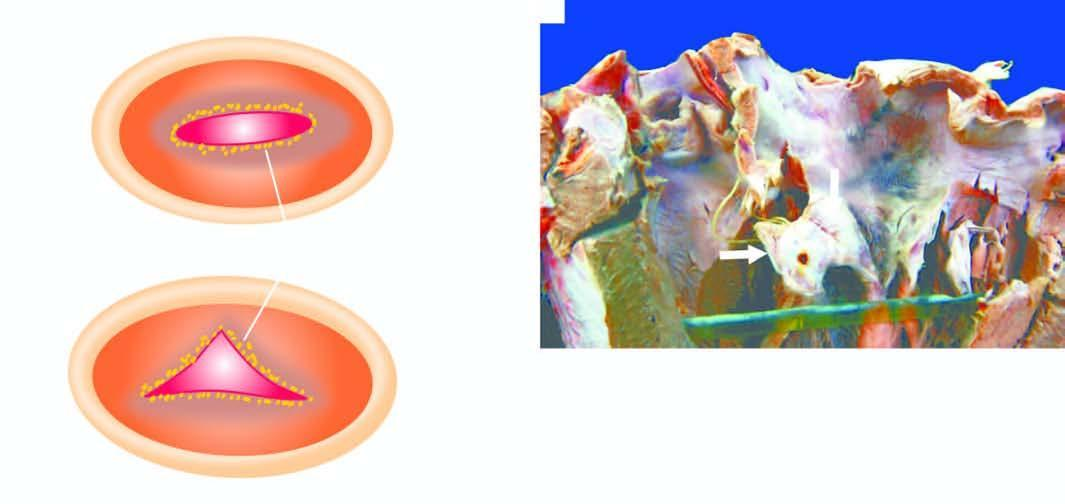does the free surface and margin of the mitral valve show tiny firm granular vegetations?
Answer the question using a single word or phrase. Yes 